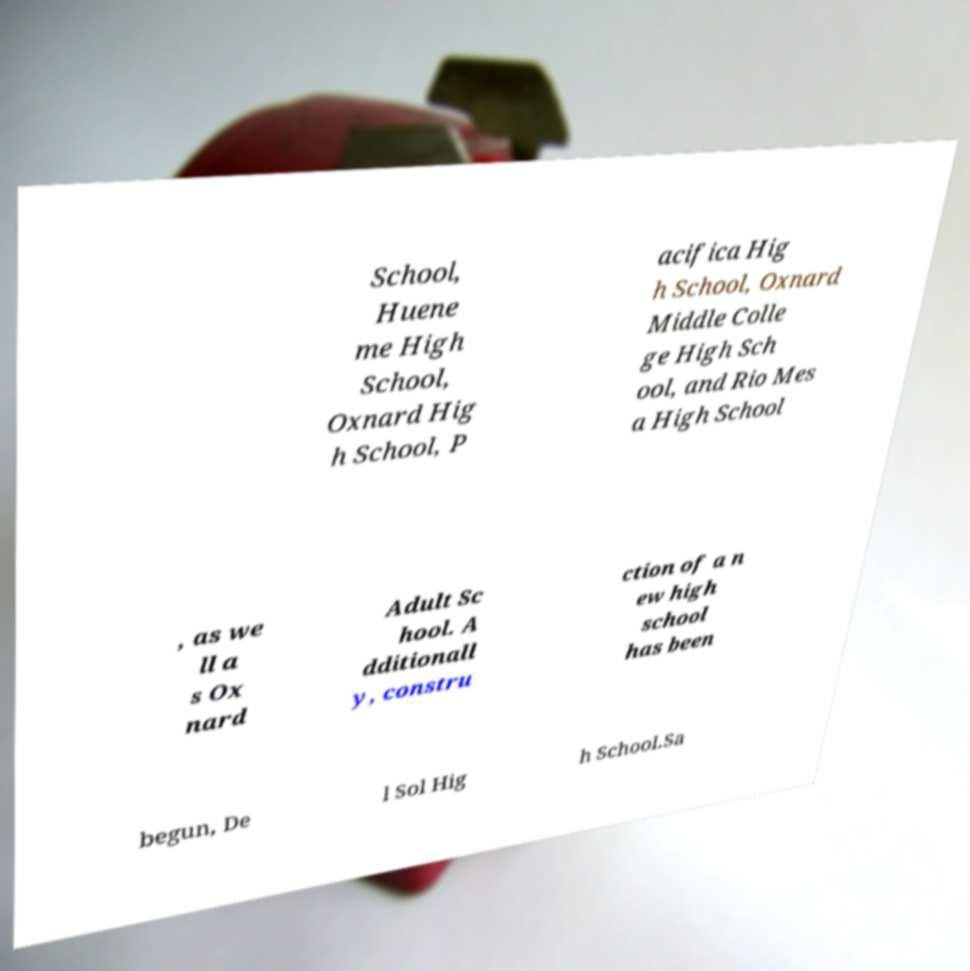Could you extract and type out the text from this image? School, Huene me High School, Oxnard Hig h School, P acifica Hig h School, Oxnard Middle Colle ge High Sch ool, and Rio Mes a High School , as we ll a s Ox nard Adult Sc hool. A dditionall y, constru ction of a n ew high school has been begun, De l Sol Hig h School.Sa 